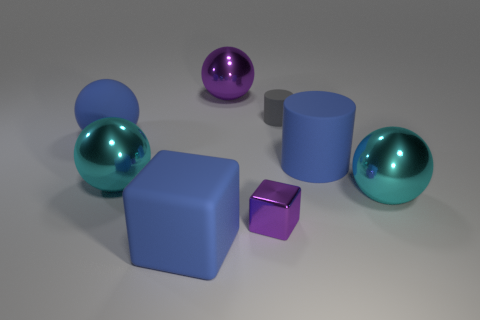Is the number of shiny balls on the left side of the purple sphere greater than the number of tiny brown things?
Give a very brief answer. Yes. Are there any tiny purple balls?
Provide a succinct answer. No. How many other objects are there of the same shape as the tiny gray matte thing?
Make the answer very short. 1. Does the metallic thing that is behind the blue sphere have the same color as the tiny object that is left of the tiny gray cylinder?
Make the answer very short. Yes. There is a purple thing in front of the tiny thing on the right side of the purple metal thing that is in front of the large purple thing; how big is it?
Ensure brevity in your answer.  Small. What shape is the blue rubber thing that is on the left side of the large matte cylinder and in front of the big rubber ball?
Make the answer very short. Cube. Are there an equal number of tiny gray things in front of the big rubber sphere and large blue objects behind the tiny metal object?
Offer a terse response. No. Are there any big spheres made of the same material as the gray object?
Your answer should be compact. Yes. Does the object that is on the right side of the large cylinder have the same material as the large blue block?
Offer a very short reply. No. What is the size of the rubber thing that is left of the small gray rubber cylinder and behind the big blue cylinder?
Keep it short and to the point. Large. 